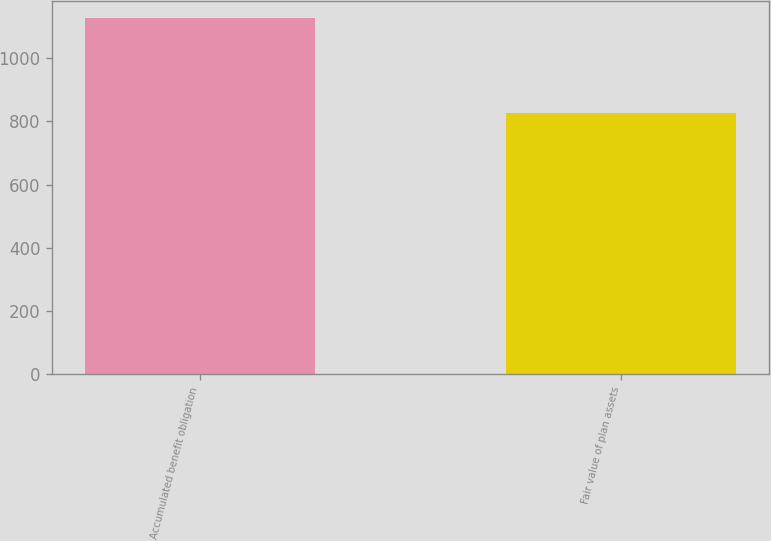<chart> <loc_0><loc_0><loc_500><loc_500><bar_chart><fcel>Accumulated benefit obligation<fcel>Fair value of plan assets<nl><fcel>1126.3<fcel>825.5<nl></chart> 